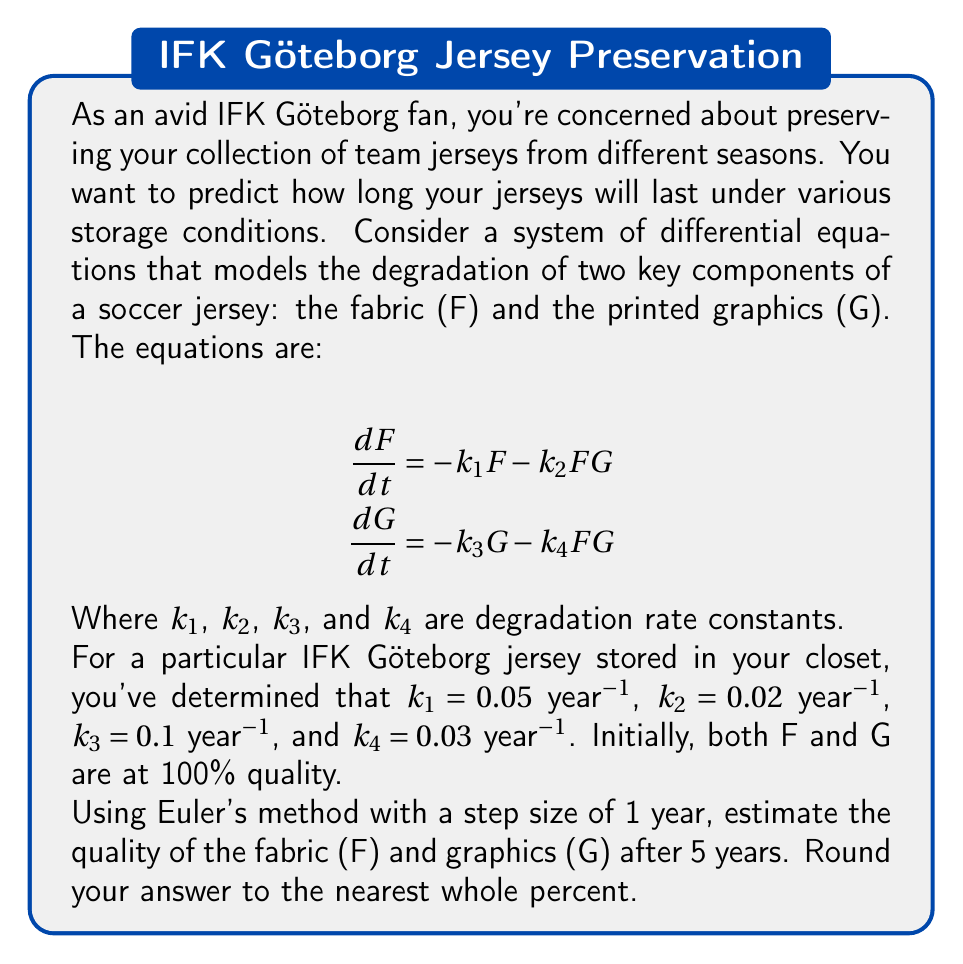Help me with this question. To solve this problem using Euler's method, we'll follow these steps:

1) Set up initial conditions:
   $F_0 = 100\%$, $G_0 = 100\%$, $t_0 = 0$ years

2) Use Euler's method formula:
   $F_{n+1} = F_n + h \cdot \frac{dF}{dt}|_{t=t_n}$
   $G_{n+1} = G_n + h \cdot \frac{dG}{dt}|_{t=t_n}$

   Where $h = 1$ year (step size)

3) Calculate for each year:

Year 1:
$\frac{dF}{dt} = -0.05F - 0.02FG = -0.05(100) - 0.02(100)(100) = -205$
$\frac{dG}{dt} = -0.1G - 0.03FG = -0.1(100) - 0.03(100)(100) = -310$

$F_1 = 100 + 1 \cdot (-205) = -105\%$ (set to 0% as quality can't be negative)
$G_1 = 100 + 1 \cdot (-310) = -210\%$ (set to 0% as quality can't be negative)

Year 2-5:
Both F and G remain at 0% as they can't decrease further.

4) Final values after 5 years:
   $F_5 = 0\%$
   $G_5 = 0\%$
Answer: Fabric: 0%, Graphics: 0% 